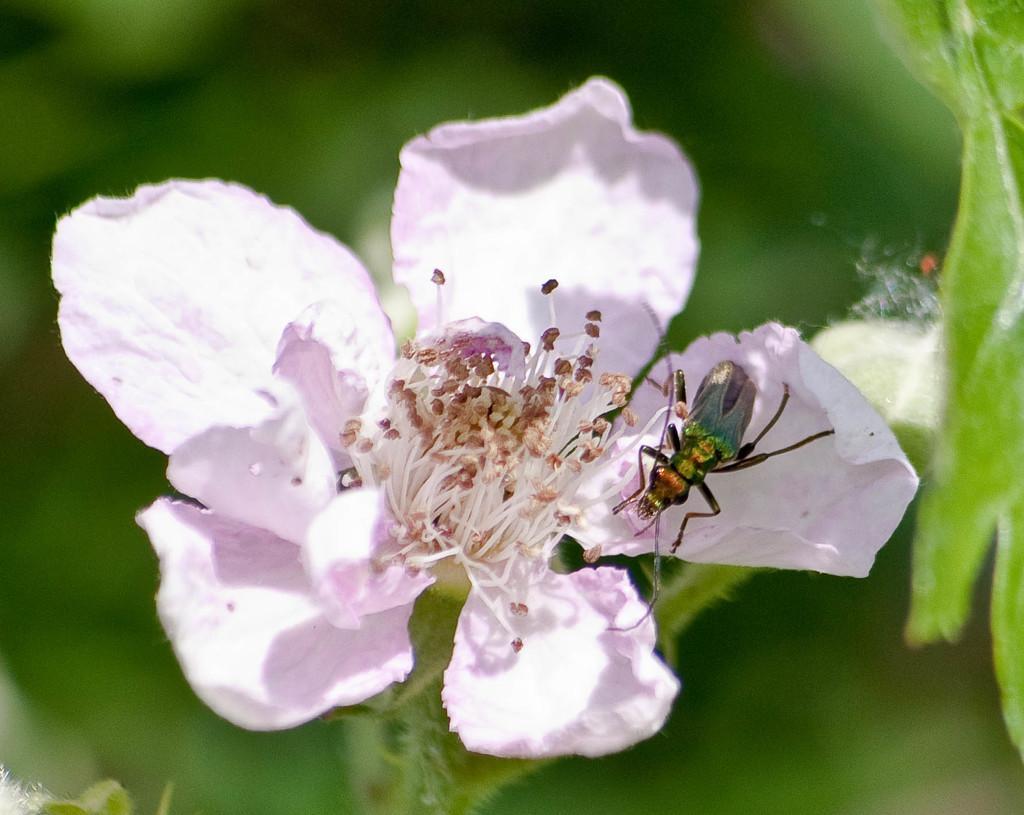How would you summarize this image in a sentence or two? In this image, I can see a flower with petals and pollen grains. This looks like an insect, which is on the flower. The background looks green in color, which is blur. 